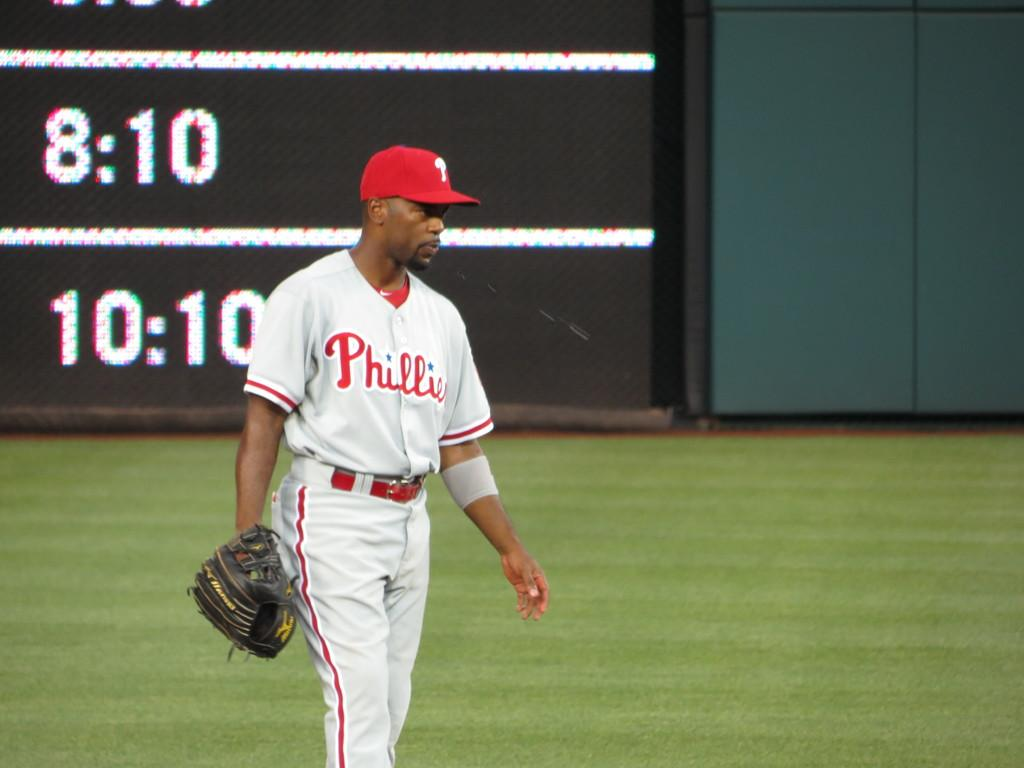<image>
Create a compact narrative representing the image presented. A Phillies baseball player stands in the outfield with his glove in the right hand. 